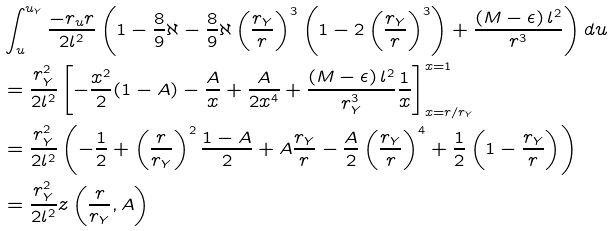<formula> <loc_0><loc_0><loc_500><loc_500>& \int ^ { u _ { Y } } _ { u } \frac { - r _ { u } r } { 2 l ^ { 2 } } \left ( 1 - \frac { 8 } { 9 } \aleph - \frac { 8 } { 9 } \aleph \left ( \frac { r _ { Y } } { r } \right ) ^ { 3 } \left ( 1 - 2 \left ( \frac { r _ { Y } } { r } \right ) ^ { 3 } \right ) + \frac { \left ( M - \epsilon \right ) l ^ { 2 } } { r ^ { 3 } } \right ) d u \\ & = \frac { r _ { Y } ^ { 2 } } { 2 l ^ { 2 } } \left [ - \frac { x ^ { 2 } } { 2 } ( 1 - A ) - \frac { A } { x } + \frac { A } { 2 x ^ { 4 } } + \frac { \left ( M - \epsilon \right ) l ^ { 2 } } { r _ { Y } ^ { 3 } } \frac { 1 } { x } \right ] _ { x = r / r _ { Y } } ^ { x = 1 } \\ & = \frac { r _ { Y } ^ { 2 } } { 2 l ^ { 2 } } \left ( - \frac { 1 } { 2 } + \left ( \frac { r } { r _ { Y } } \right ) ^ { 2 } \frac { 1 - A } { 2 } + A \frac { r _ { Y } } { r } - \frac { A } { 2 } \left ( \frac { r _ { Y } } { r } \right ) ^ { 4 } + \frac { 1 } { 2 } \left ( 1 - \frac { r _ { Y } } { r } \right ) \right ) \\ & = \frac { r _ { Y } ^ { 2 } } { 2 l ^ { 2 } } z \left ( \frac { r } { r _ { Y } } , A \right )</formula> 